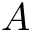Convert formula to latex. <formula><loc_0><loc_0><loc_500><loc_500>A</formula> 